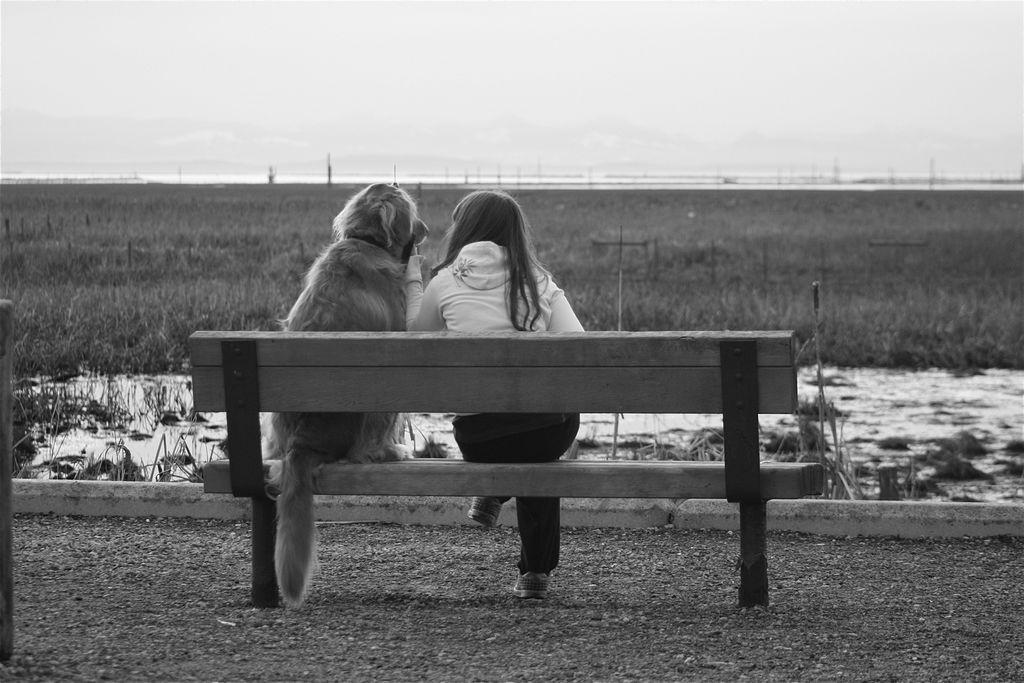What is the color scheme of the image? The image is black and white. What type of object can be seen in the image? There is a bench in the image. What is sitting on the bench? A dog and a girl are sitting on the bench. What type of advertisement is displayed on the bench in the image? There is no advertisement present on the bench in the image. Can you tell me how many children are sitting on the bench? There is only one girl sitting on the bench, not multiple children. 